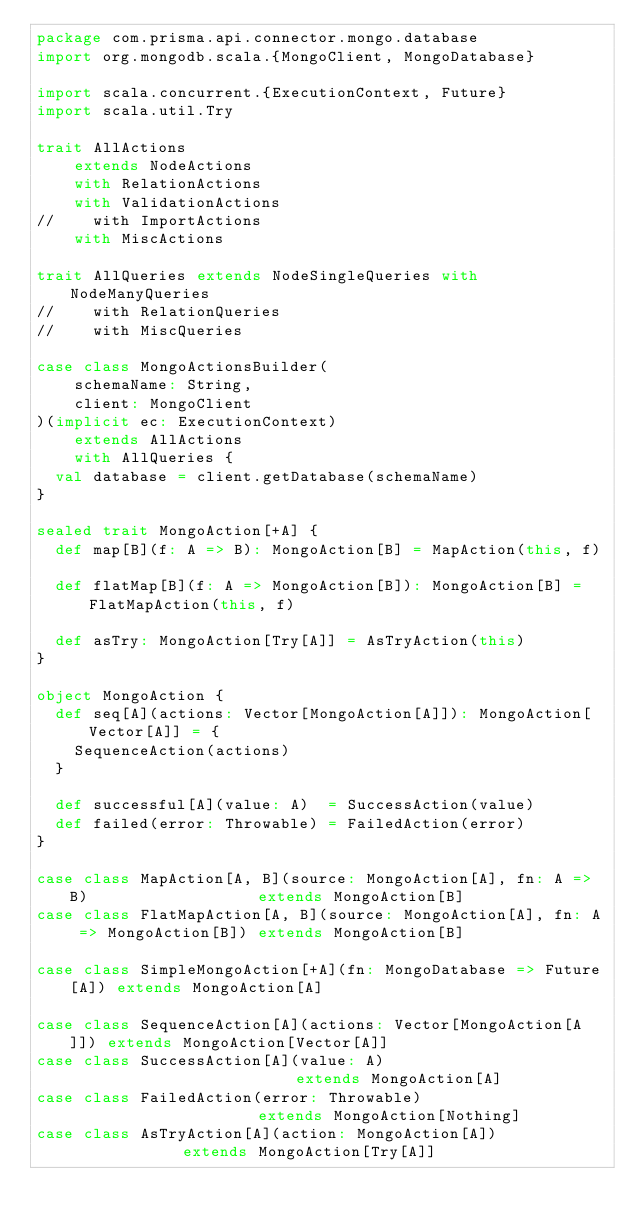<code> <loc_0><loc_0><loc_500><loc_500><_Scala_>package com.prisma.api.connector.mongo.database
import org.mongodb.scala.{MongoClient, MongoDatabase}

import scala.concurrent.{ExecutionContext, Future}
import scala.util.Try

trait AllActions
    extends NodeActions
    with RelationActions
    with ValidationActions
//    with ImportActions
    with MiscActions

trait AllQueries extends NodeSingleQueries with NodeManyQueries
//    with RelationQueries
//    with MiscQueries

case class MongoActionsBuilder(
    schemaName: String,
    client: MongoClient
)(implicit ec: ExecutionContext)
    extends AllActions
    with AllQueries {
  val database = client.getDatabase(schemaName)
}

sealed trait MongoAction[+A] {
  def map[B](f: A => B): MongoAction[B] = MapAction(this, f)

  def flatMap[B](f: A => MongoAction[B]): MongoAction[B] = FlatMapAction(this, f)

  def asTry: MongoAction[Try[A]] = AsTryAction(this)
}

object MongoAction {
  def seq[A](actions: Vector[MongoAction[A]]): MongoAction[Vector[A]] = {
    SequenceAction(actions)
  }

  def successful[A](value: A)  = SuccessAction(value)
  def failed(error: Throwable) = FailedAction(error)
}

case class MapAction[A, B](source: MongoAction[A], fn: A => B)                  extends MongoAction[B]
case class FlatMapAction[A, B](source: MongoAction[A], fn: A => MongoAction[B]) extends MongoAction[B]

case class SimpleMongoAction[+A](fn: MongoDatabase => Future[A]) extends MongoAction[A]

case class SequenceAction[A](actions: Vector[MongoAction[A]]) extends MongoAction[Vector[A]]
case class SuccessAction[A](value: A)                         extends MongoAction[A]
case class FailedAction(error: Throwable)                     extends MongoAction[Nothing]
case class AsTryAction[A](action: MongoAction[A])             extends MongoAction[Try[A]]
</code> 